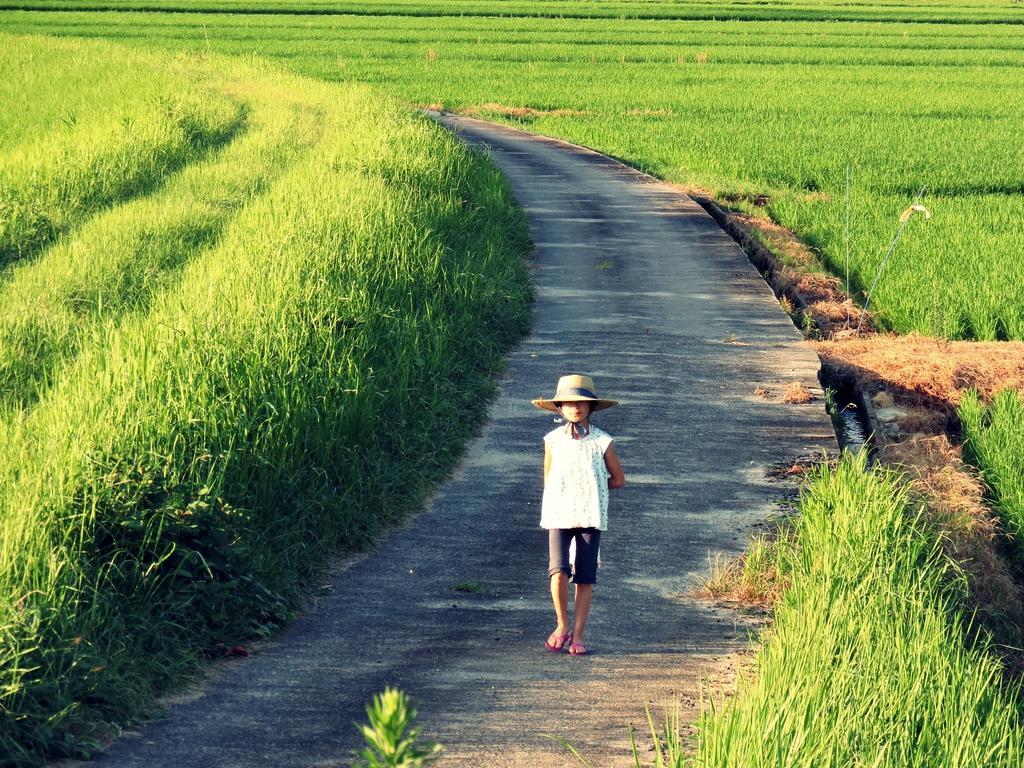Please provide a concise description of this image. In this image we can see a boy with a hat walking on the road. Image also consists of grass. 